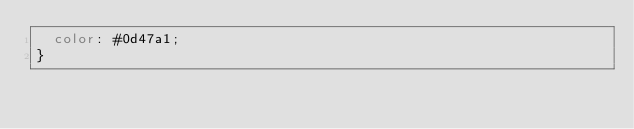Convert code to text. <code><loc_0><loc_0><loc_500><loc_500><_CSS_>  color: #0d47a1;
}
</code> 